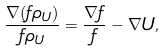Convert formula to latex. <formula><loc_0><loc_0><loc_500><loc_500>\frac { \nabla ( f \rho _ { U } ) } { f \rho _ { U } } = \frac { \nabla f } { f } - \nabla U ,</formula> 